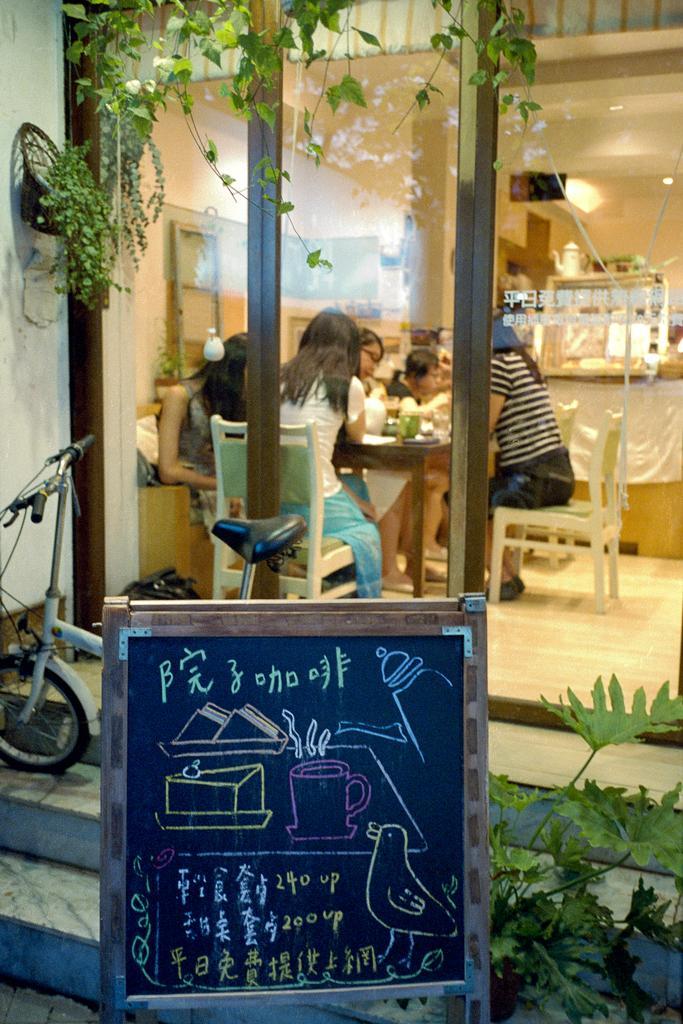Describe this image in one or two sentences. In this picture we can see a group of people sitting on chair and in front of them there is table and on table we can see glasses, jars and in front we have bicycle, board, plants and in background we can see wall, teapot. 